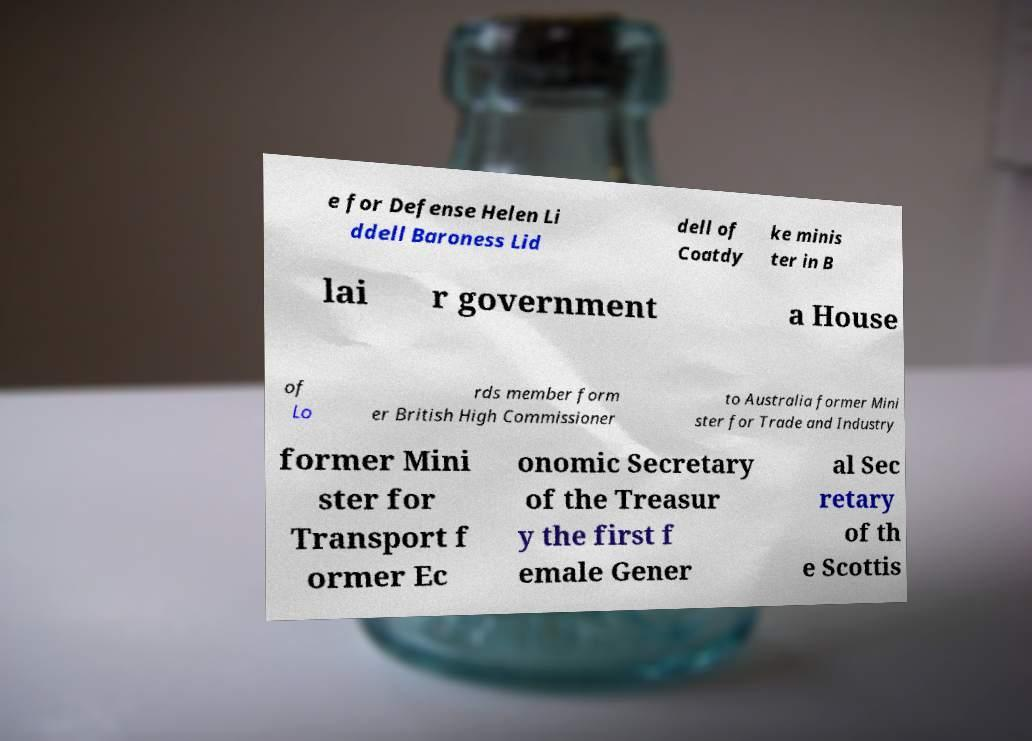There's text embedded in this image that I need extracted. Can you transcribe it verbatim? e for Defense Helen Li ddell Baroness Lid dell of Coatdy ke minis ter in B lai r government a House of Lo rds member form er British High Commissioner to Australia former Mini ster for Trade and Industry former Mini ster for Transport f ormer Ec onomic Secretary of the Treasur y the first f emale Gener al Sec retary of th e Scottis 